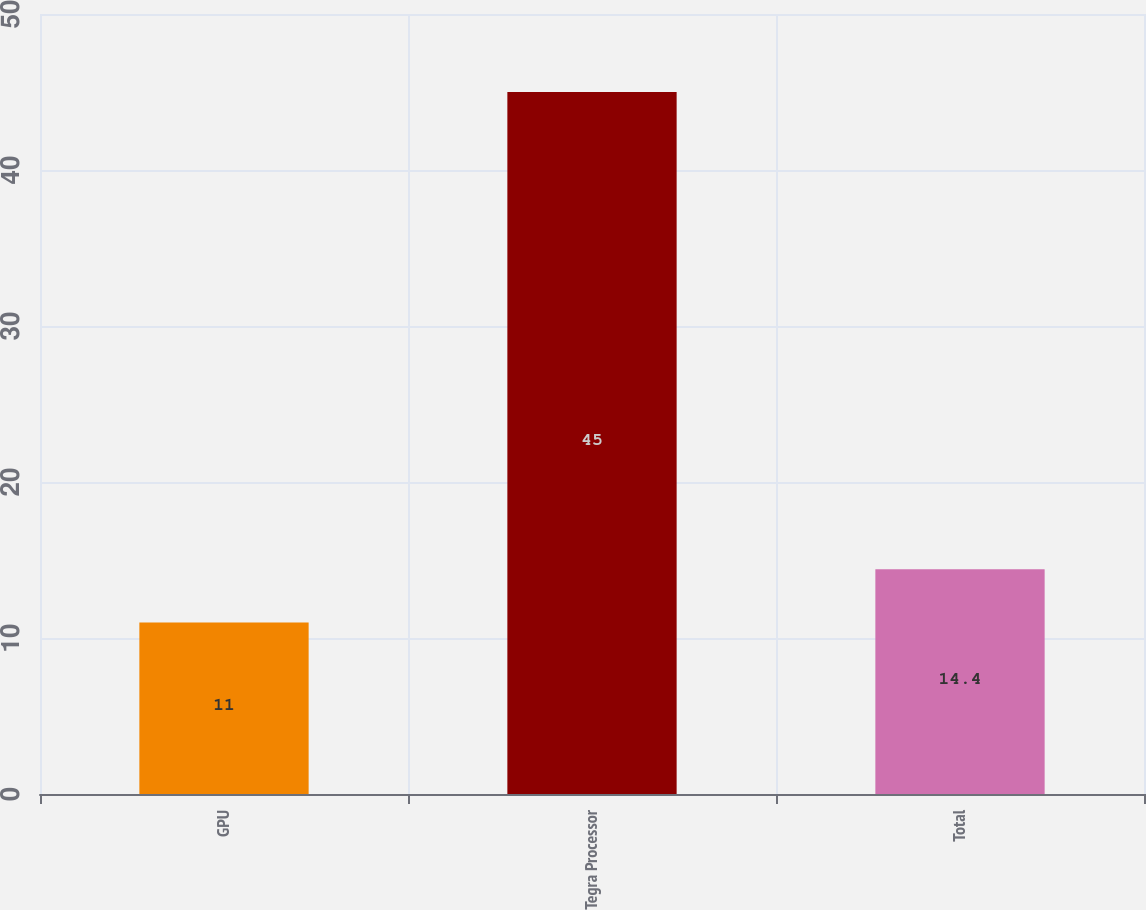Convert chart. <chart><loc_0><loc_0><loc_500><loc_500><bar_chart><fcel>GPU<fcel>Tegra Processor<fcel>Total<nl><fcel>11<fcel>45<fcel>14.4<nl></chart> 